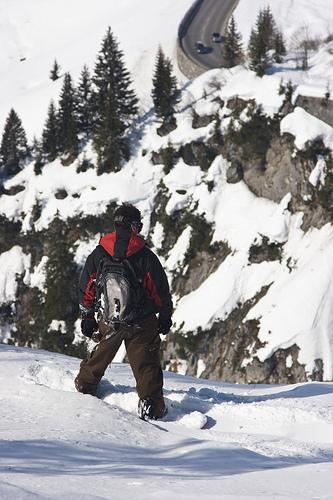Question: why is there snow?
Choices:
A. It's the mountains.
B. It's Colorado.
C. It's cold.
D. Winter.
Answer with the letter. Answer: D Question: who is standing in the snow?
Choices:
A. A bear.
B. The person.
C. Two dogs.
D. Nobody.
Answer with the letter. Answer: B Question: where are the goggles?
Choices:
A. On the man's head.
B. THe persons head.
C. In the pool.
D. Over his head.
Answer with the letter. Answer: B 